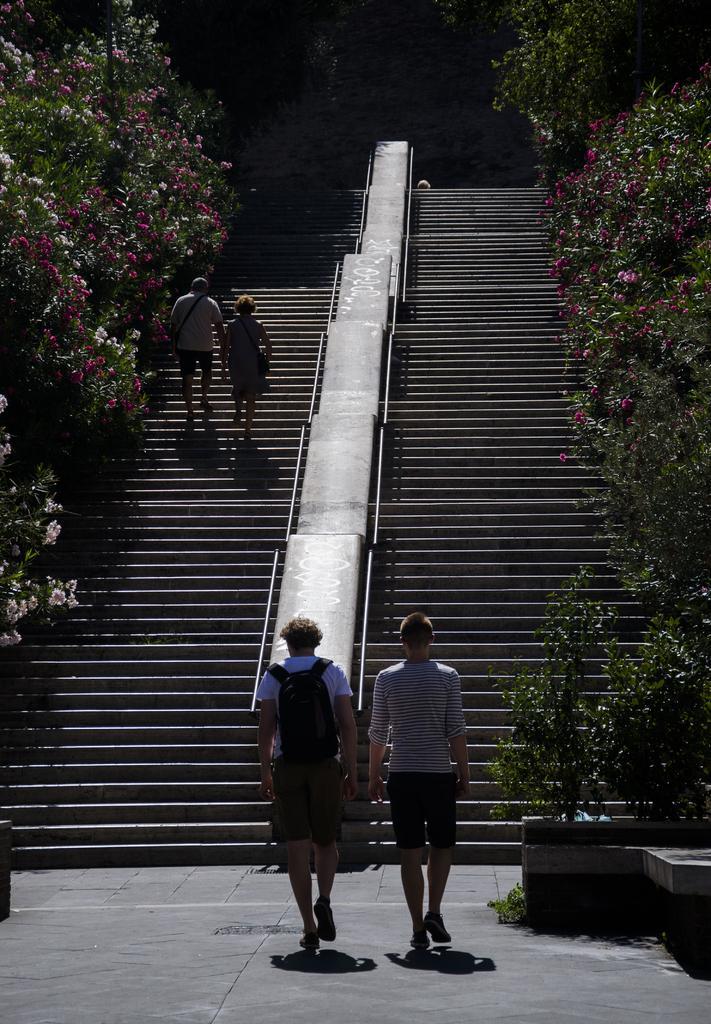How would you summarize this image in a sentence or two? In this picture I can observe four members. Two of them are on the stairs. In the middle of the picture I can observe stairs. On either sides of the picture I can observe trees. 